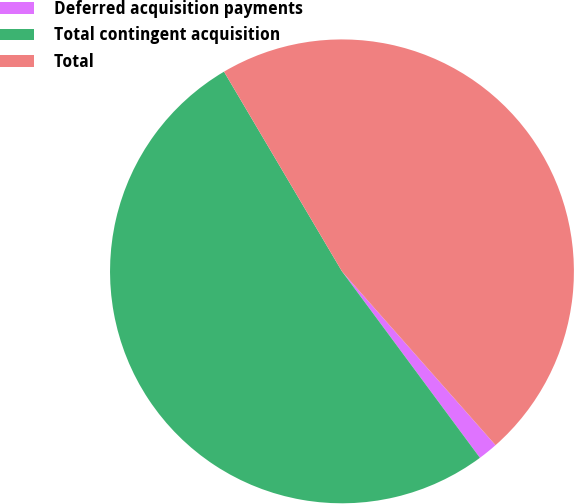<chart> <loc_0><loc_0><loc_500><loc_500><pie_chart><fcel>Deferred acquisition payments<fcel>Total contingent acquisition<fcel>Total<nl><fcel>1.38%<fcel>51.64%<fcel>46.97%<nl></chart> 